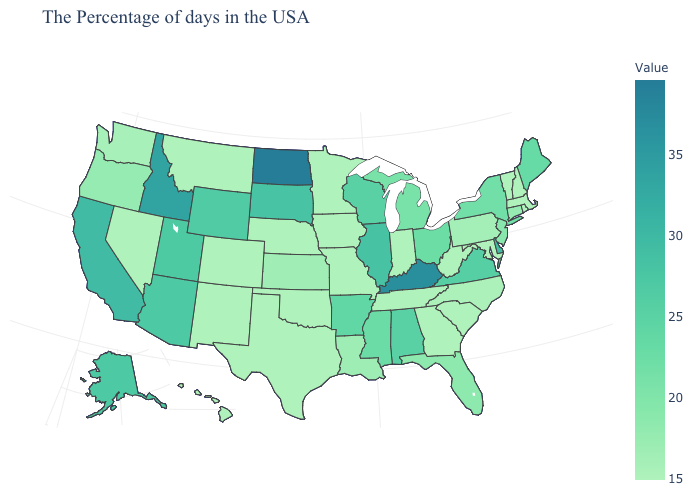Is the legend a continuous bar?
Be succinct. Yes. Is the legend a continuous bar?
Be succinct. Yes. Which states have the lowest value in the USA?
Be succinct. Massachusetts, Rhode Island, New Hampshire, Vermont, Maryland, South Carolina, West Virginia, Georgia, Indiana, Tennessee, Missouri, Minnesota, Iowa, Nebraska, Oklahoma, Texas, Colorado, New Mexico, Montana, Nevada, Hawaii. Is the legend a continuous bar?
Be succinct. Yes. Among the states that border West Virginia , does Ohio have the highest value?
Concise answer only. No. Does the map have missing data?
Quick response, please. No. 